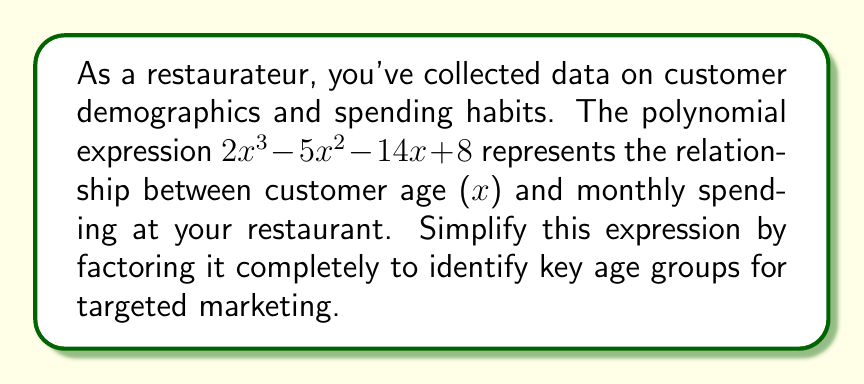Can you answer this question? To simplify the polynomial expression $2x^3 - 5x^2 - 14x + 8$ by factoring, we'll follow these steps:

1) First, let's check if there's a greatest common factor (GCF):
   $GCF(2x^3, -5x^2, -14x, 8) = 1$
   There's no common factor, so we proceed to the next step.

2) This is a cubic equation, so we'll try to factor out a linear term:
   Let's guess some factors of the constant term (8): ±1, ±2, ±4, ±8
   We find that $(x - 2)$ is a factor:

   $2x^3 - 5x^2 - 14x + 8 = (x - 2)(2x^2 + ax + b)$

3) We can find $a$ and $b$ by comparing coefficients:
   $2x^2 + ax - 4 = 2x^2 - x - 7$
   Therefore, $a = -1$ and $b = -7$

4) Now we have:
   $2x^3 - 5x^2 - 14x + 8 = (x - 2)(2x^2 - x - 7)$

5) The quadratic factor $2x^2 - x - 7$ can be further factored:
   $2x^2 - x - 7 = (2x + 3)(x - 2)$

6) Therefore, the fully factored expression is:
   $2x^3 - 5x^2 - 14x + 8 = (x - 2)(2x + 3)(x - 2)$
   $= (x - 2)^2(2x + 3)$

This factored form reveals key age groups for targeted marketing:
- $x = 2$ represents a significant age group (occurring twice)
- $x = -\frac{3}{2}$ represents another important point, though not a realistic age

For a restaurateur, this suggests focusing marketing efforts on customers around 22 years old (x = 2 + 20, assuming x represents years above 20), as this age appears to have a strong influence on spending patterns.
Answer: $(x - 2)^2(2x + 3)$ 